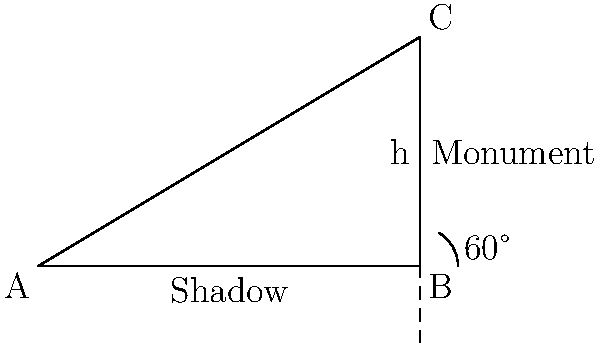As a religious leader seeking to understand the physical world through the lens of faith, you are tasked with determining the height of a sacred monument. On a sunny day, you observe that the monument casts a shadow 5 meters long when the angle of elevation of the sun is 60°. Using principles of trigonometry, calculate the height of the monument. How might this calculation deepen your appreciation for the divine order in mathematics and nature? Let's approach this step-by-step, reflecting on how mathematical principles can reveal the harmony in God's creation:

1) First, we identify the relevant trigonometric function. The tangent of an angle in a right triangle is the ratio of the opposite side to the adjacent side.

2) In this case:
   - The angle of elevation is 60°
   - The adjacent side is the shadow length (5 meters)
   - The opposite side is the height of the monument (h)

3) We can express this relationship as:

   $$\tan(60°) = \frac{h}{5}$$

4) We know that $\tan(60°) = \sqrt{3}$. Substituting this:

   $$\sqrt{3} = \frac{h}{5}$$

5) To solve for h, multiply both sides by 5:

   $$5\sqrt{3} = h$$

6) Simplify:

   $$h = 5\sqrt{3} \approx 8.66 \text{ meters}$$

This calculation demonstrates how mathematical principles can help us understand and measure the physical world, revealing the intricate design in nature that many see as evidence of divine creation.
Answer: $5\sqrt{3}$ meters or approximately 8.66 meters 